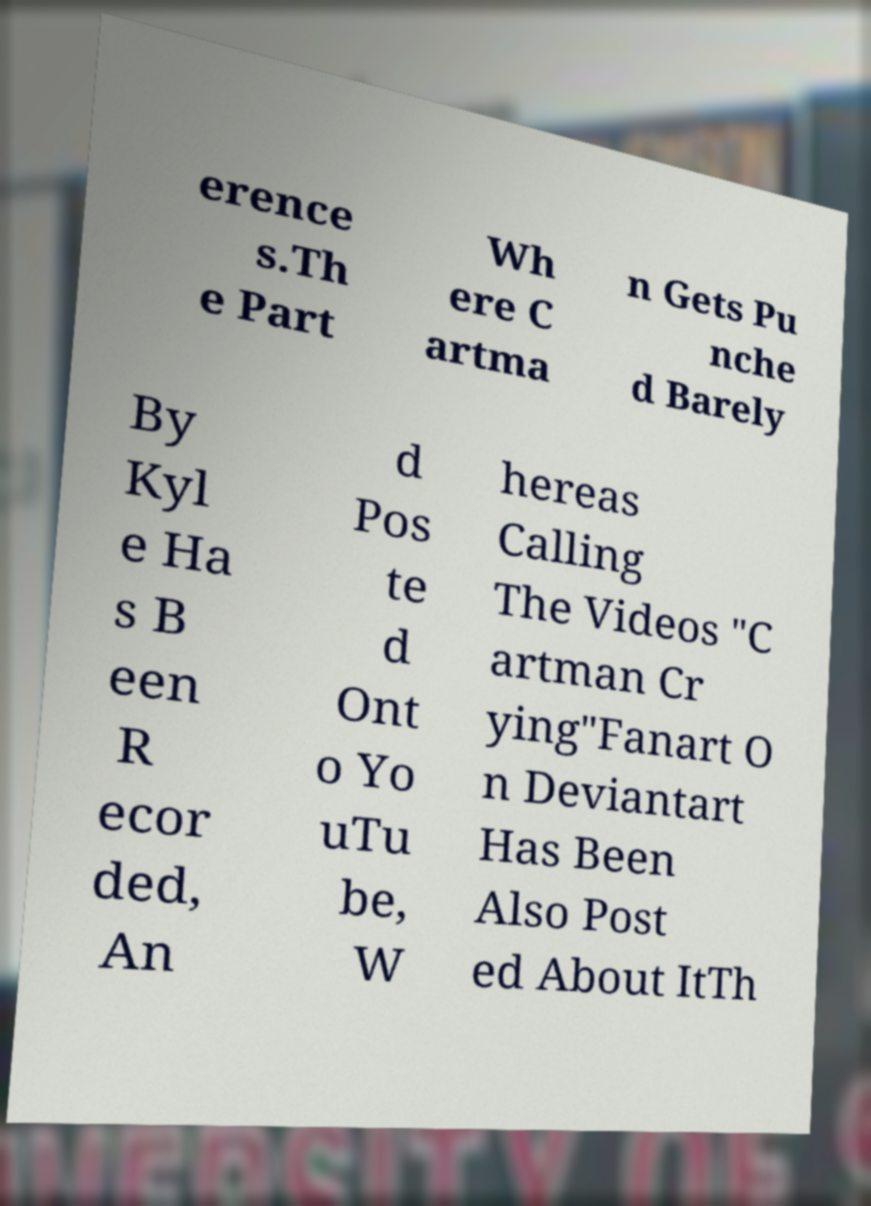Please identify and transcribe the text found in this image. erence s.Th e Part Wh ere C artma n Gets Pu nche d Barely By Kyl e Ha s B een R ecor ded, An d Pos te d Ont o Yo uTu be, W hereas Calling The Videos "C artman Cr ying"Fanart O n Deviantart Has Been Also Post ed About ItTh 